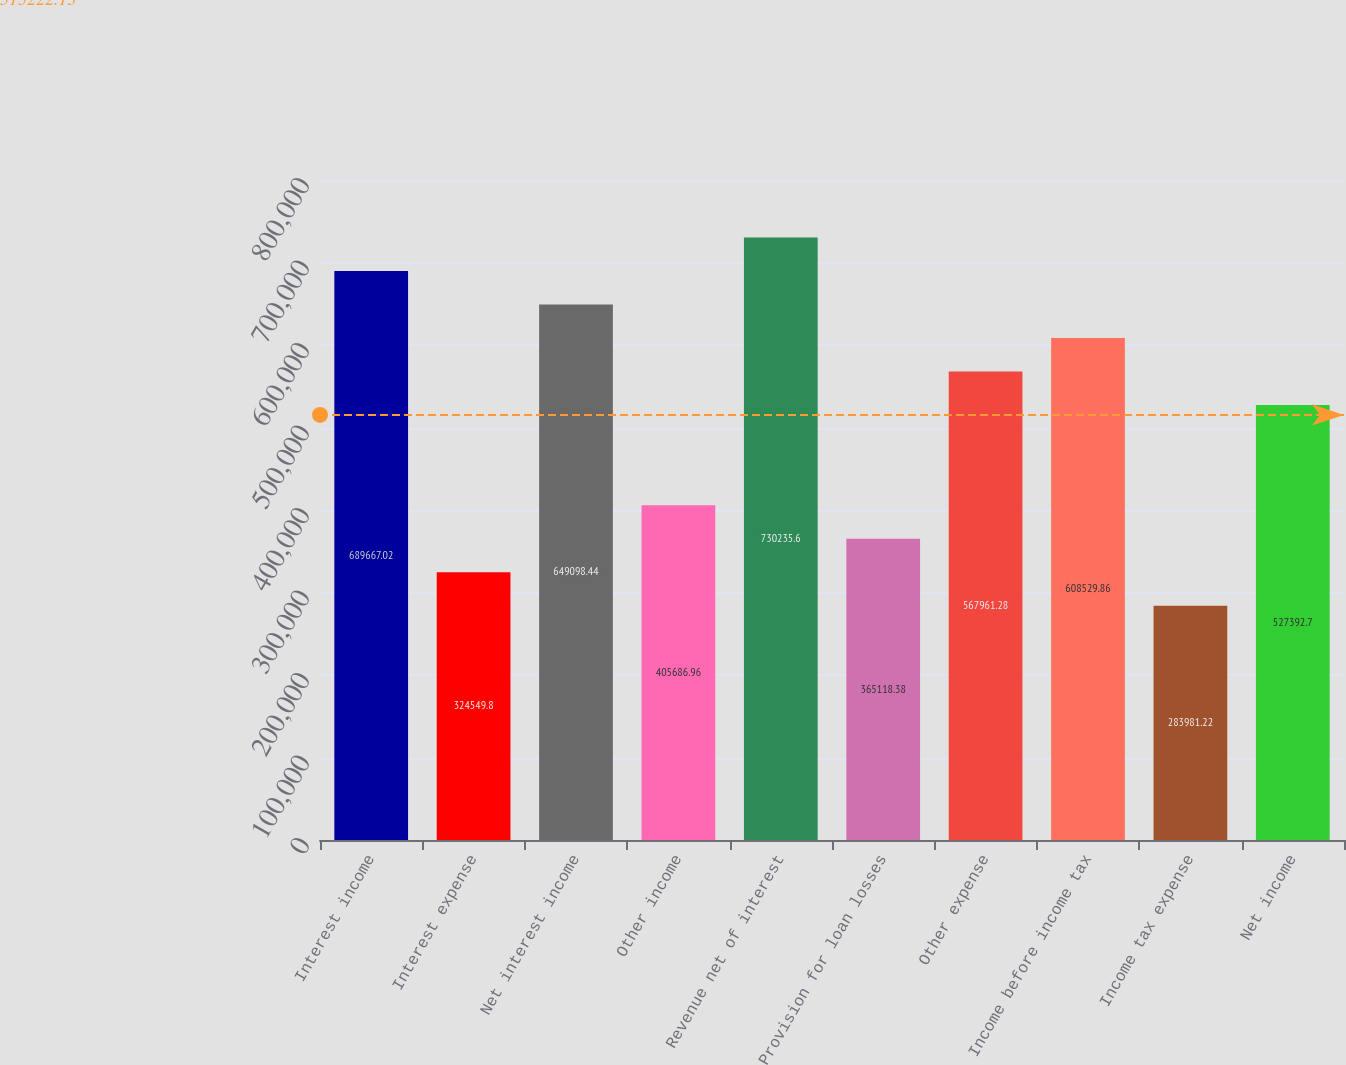Convert chart to OTSL. <chart><loc_0><loc_0><loc_500><loc_500><bar_chart><fcel>Interest income<fcel>Interest expense<fcel>Net interest income<fcel>Other income<fcel>Revenue net of interest<fcel>Provision for loan losses<fcel>Other expense<fcel>Income before income tax<fcel>Income tax expense<fcel>Net income<nl><fcel>689667<fcel>324550<fcel>649098<fcel>405687<fcel>730236<fcel>365118<fcel>567961<fcel>608530<fcel>283981<fcel>527393<nl></chart> 